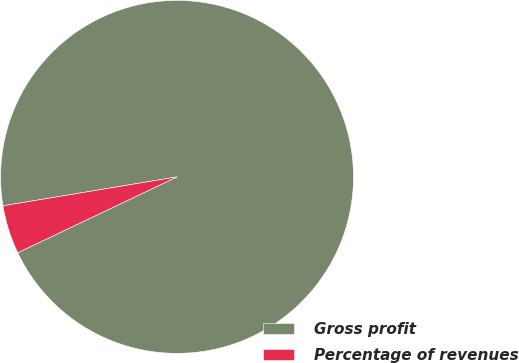<chart> <loc_0><loc_0><loc_500><loc_500><pie_chart><fcel>Gross profit<fcel>Percentage of revenues<nl><fcel>95.55%<fcel>4.45%<nl></chart> 